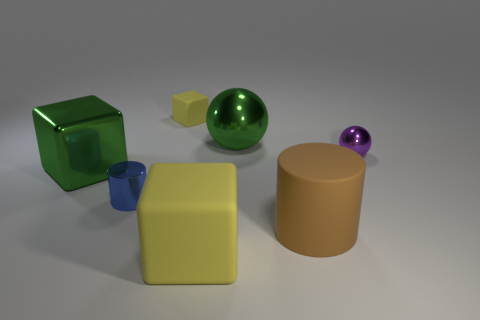How many small blue cylinders are made of the same material as the green ball?
Your answer should be very brief. 1. What number of green metal things are there?
Make the answer very short. 2. Is the color of the ball that is right of the big green sphere the same as the block to the left of the blue shiny cylinder?
Ensure brevity in your answer.  No. How many metal objects are behind the purple sphere?
Ensure brevity in your answer.  1. There is a big object that is the same color as the big metallic sphere; what material is it?
Give a very brief answer. Metal. Are there any tiny green matte things of the same shape as the tiny blue metal object?
Give a very brief answer. No. Do the yellow cube behind the small blue cylinder and the purple ball right of the metal cube have the same material?
Keep it short and to the point. No. What size is the yellow object behind the large rubber object on the right side of the block that is in front of the small blue cylinder?
Provide a succinct answer. Small. What is the material of the green ball that is the same size as the brown thing?
Ensure brevity in your answer.  Metal. Are there any green rubber cubes of the same size as the purple metallic ball?
Your answer should be very brief. No. 